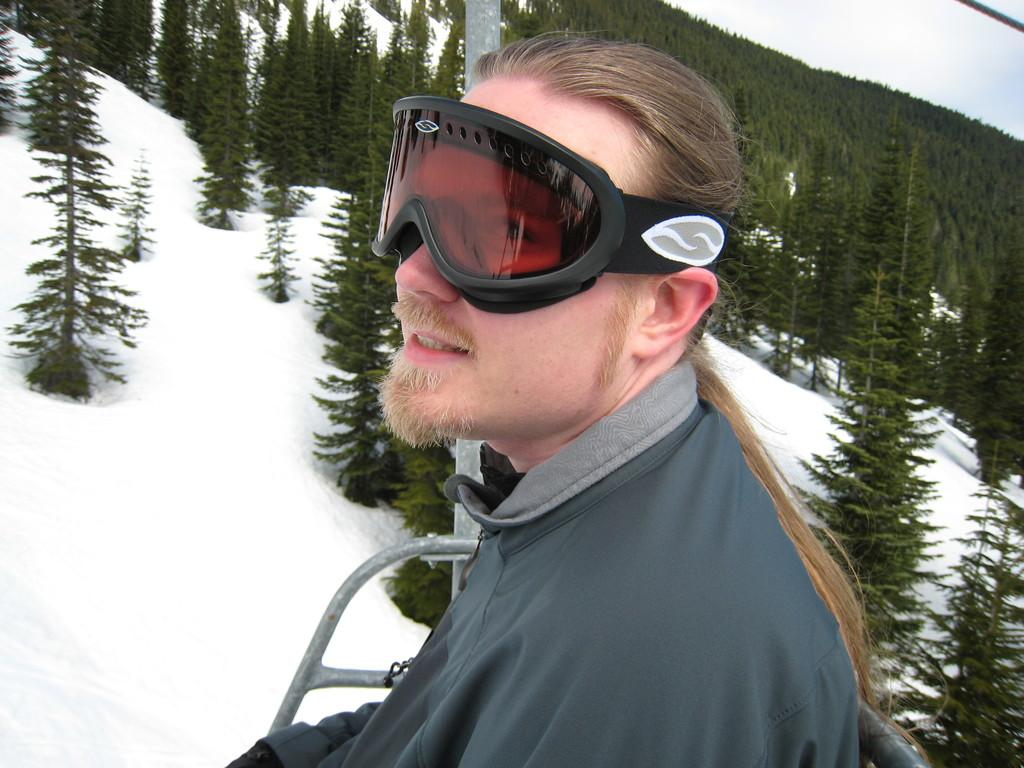What type of vegetation can be seen in the image? There are trees in the image. What geographical feature is present in the image? There is a hill in the image. What weather condition is depicted in the image? There is snow visible in the image. What mode of transportation is the man using in the image? The man is sitting in a rope car. What accessory is the man wearing in the image? The man is wearing sunglasses. What is visible in the sky in the image? The sky is visible in the image. What type of division can be seen in the image? There is no division present in the image; it features a hill, trees, snow, a rope car, sunglasses, and a sky. Is there a turkey visible in the image? No, there is no turkey present in the image. 